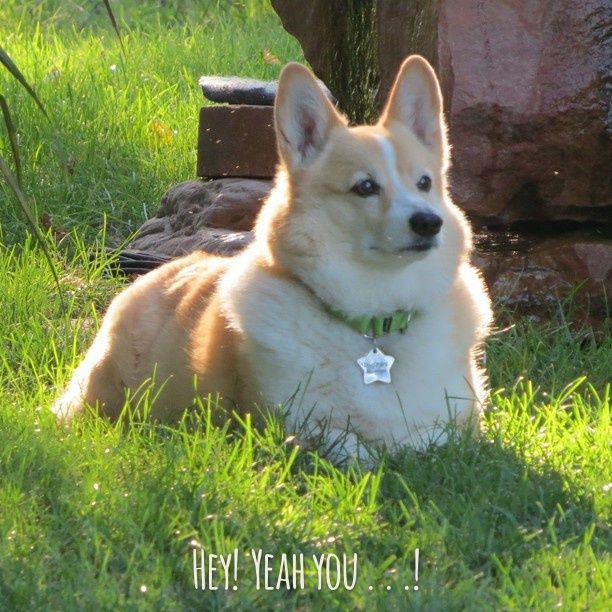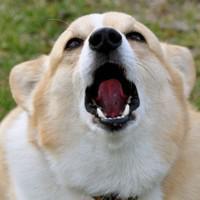The first image is the image on the left, the second image is the image on the right. Assess this claim about the two images: "One image features a dog wearing a collar with a star-shaped tag.". Correct or not? Answer yes or no. Yes. The first image is the image on the left, the second image is the image on the right. Considering the images on both sides, is "The dog in the left photo has a star shapped tag hanging from its collar." valid? Answer yes or no. Yes. 